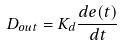<formula> <loc_0><loc_0><loc_500><loc_500>D _ { o u t } = K _ { d } \frac { d e ( t ) } { d t }</formula> 